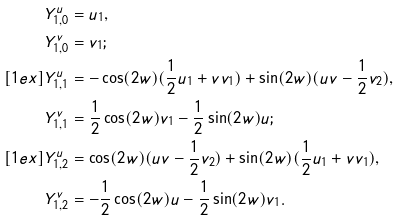Convert formula to latex. <formula><loc_0><loc_0><loc_500><loc_500>Y _ { 1 , 0 } ^ { u } & = u _ { 1 } , \\ Y _ { 1 , 0 } ^ { v } & = v _ { 1 } ; \\ [ 1 e x ] Y _ { 1 , 1 } ^ { u } & = - \cos ( 2 w ) ( \frac { 1 } { 2 } u _ { 1 } + v v _ { 1 } ) + \sin ( 2 w ) ( u v - \frac { 1 } { 2 } v _ { 2 } ) , \\ Y _ { 1 , 1 } ^ { v } & = \frac { 1 } { 2 } \cos ( 2 w ) v _ { 1 } - \frac { 1 } { 2 } \sin ( 2 w ) u ; \\ [ 1 e x ] Y _ { 1 , 2 } ^ { u } & = \cos ( 2 w ) ( u v - \frac { 1 } { 2 } v _ { 2 } ) + \sin ( 2 w ) ( \frac { 1 } { 2 } u _ { 1 } + v v _ { 1 } ) , \\ Y _ { 1 , 2 } ^ { v } & = - \frac { 1 } { 2 } \cos ( 2 w ) u - \frac { 1 } { 2 } \sin ( 2 w ) v _ { 1 } .</formula> 